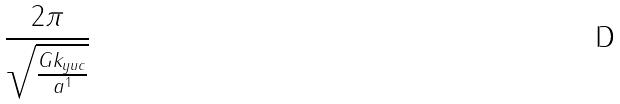<formula> <loc_0><loc_0><loc_500><loc_500>\frac { 2 \pi } { \sqrt { \frac { G k _ { y u c } } { a ^ { 1 } } } }</formula> 